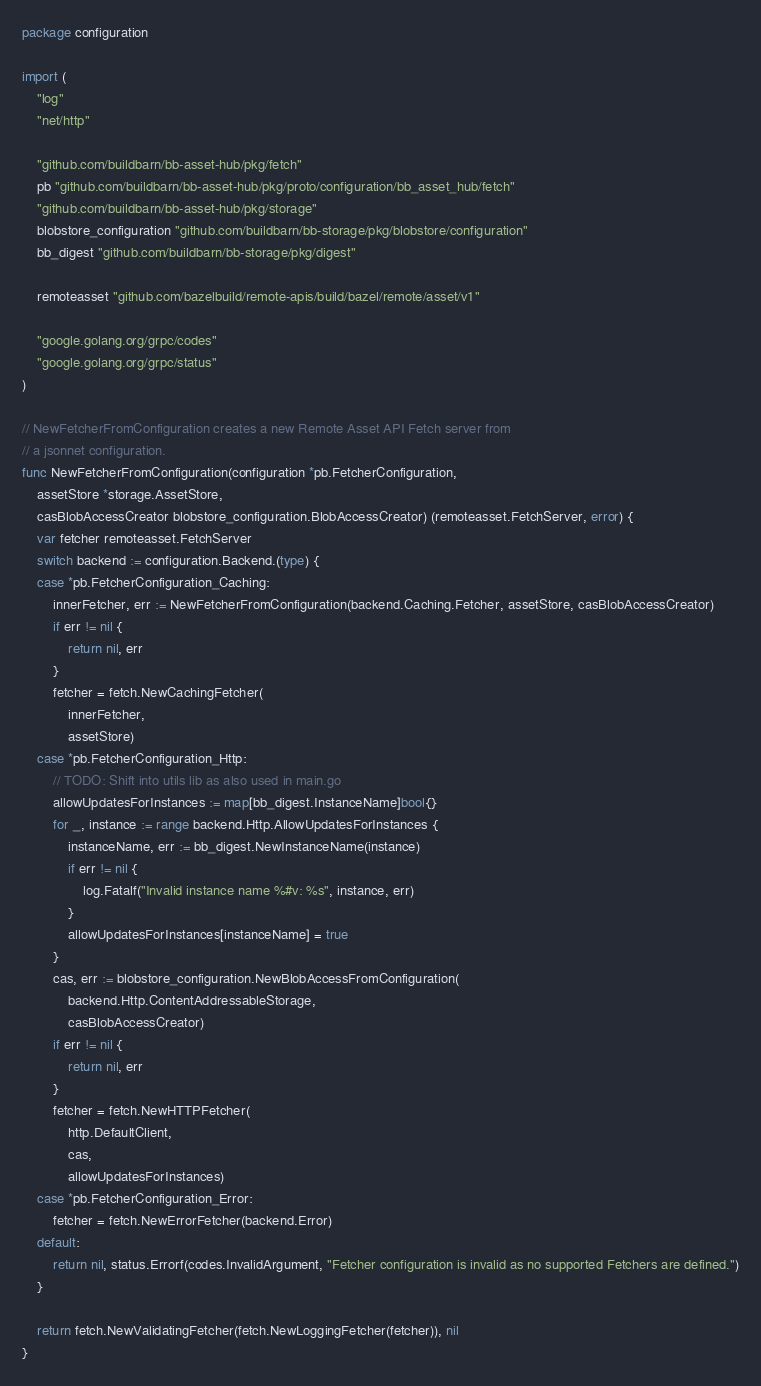<code> <loc_0><loc_0><loc_500><loc_500><_Go_>package configuration

import (
	"log"
	"net/http"

	"github.com/buildbarn/bb-asset-hub/pkg/fetch"
	pb "github.com/buildbarn/bb-asset-hub/pkg/proto/configuration/bb_asset_hub/fetch"
	"github.com/buildbarn/bb-asset-hub/pkg/storage"
	blobstore_configuration "github.com/buildbarn/bb-storage/pkg/blobstore/configuration"
	bb_digest "github.com/buildbarn/bb-storage/pkg/digest"

	remoteasset "github.com/bazelbuild/remote-apis/build/bazel/remote/asset/v1"

	"google.golang.org/grpc/codes"
	"google.golang.org/grpc/status"
)

// NewFetcherFromConfiguration creates a new Remote Asset API Fetch server from
// a jsonnet configuration.
func NewFetcherFromConfiguration(configuration *pb.FetcherConfiguration,
	assetStore *storage.AssetStore,
	casBlobAccessCreator blobstore_configuration.BlobAccessCreator) (remoteasset.FetchServer, error) {
	var fetcher remoteasset.FetchServer
	switch backend := configuration.Backend.(type) {
	case *pb.FetcherConfiguration_Caching:
		innerFetcher, err := NewFetcherFromConfiguration(backend.Caching.Fetcher, assetStore, casBlobAccessCreator)
		if err != nil {
			return nil, err
		}
		fetcher = fetch.NewCachingFetcher(
			innerFetcher,
			assetStore)
	case *pb.FetcherConfiguration_Http:
		// TODO: Shift into utils lib as also used in main.go
		allowUpdatesForInstances := map[bb_digest.InstanceName]bool{}
		for _, instance := range backend.Http.AllowUpdatesForInstances {
			instanceName, err := bb_digest.NewInstanceName(instance)
			if err != nil {
				log.Fatalf("Invalid instance name %#v: %s", instance, err)
			}
			allowUpdatesForInstances[instanceName] = true
		}
		cas, err := blobstore_configuration.NewBlobAccessFromConfiguration(
			backend.Http.ContentAddressableStorage,
			casBlobAccessCreator)
		if err != nil {
			return nil, err
		}
		fetcher = fetch.NewHTTPFetcher(
			http.DefaultClient,
			cas,
			allowUpdatesForInstances)
	case *pb.FetcherConfiguration_Error:
		fetcher = fetch.NewErrorFetcher(backend.Error)
	default:
		return nil, status.Errorf(codes.InvalidArgument, "Fetcher configuration is invalid as no supported Fetchers are defined.")
	}

	return fetch.NewValidatingFetcher(fetch.NewLoggingFetcher(fetcher)), nil
}
</code> 